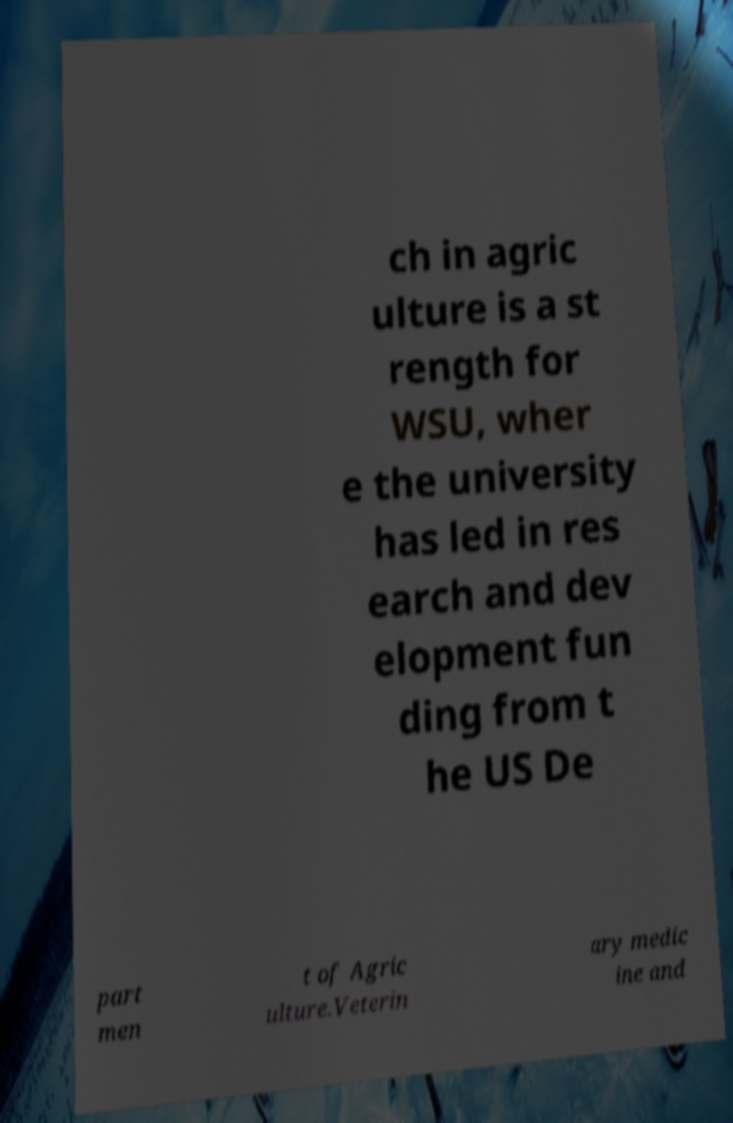I need the written content from this picture converted into text. Can you do that? ch in agric ulture is a st rength for WSU, wher e the university has led in res earch and dev elopment fun ding from t he US De part men t of Agric ulture.Veterin ary medic ine and 